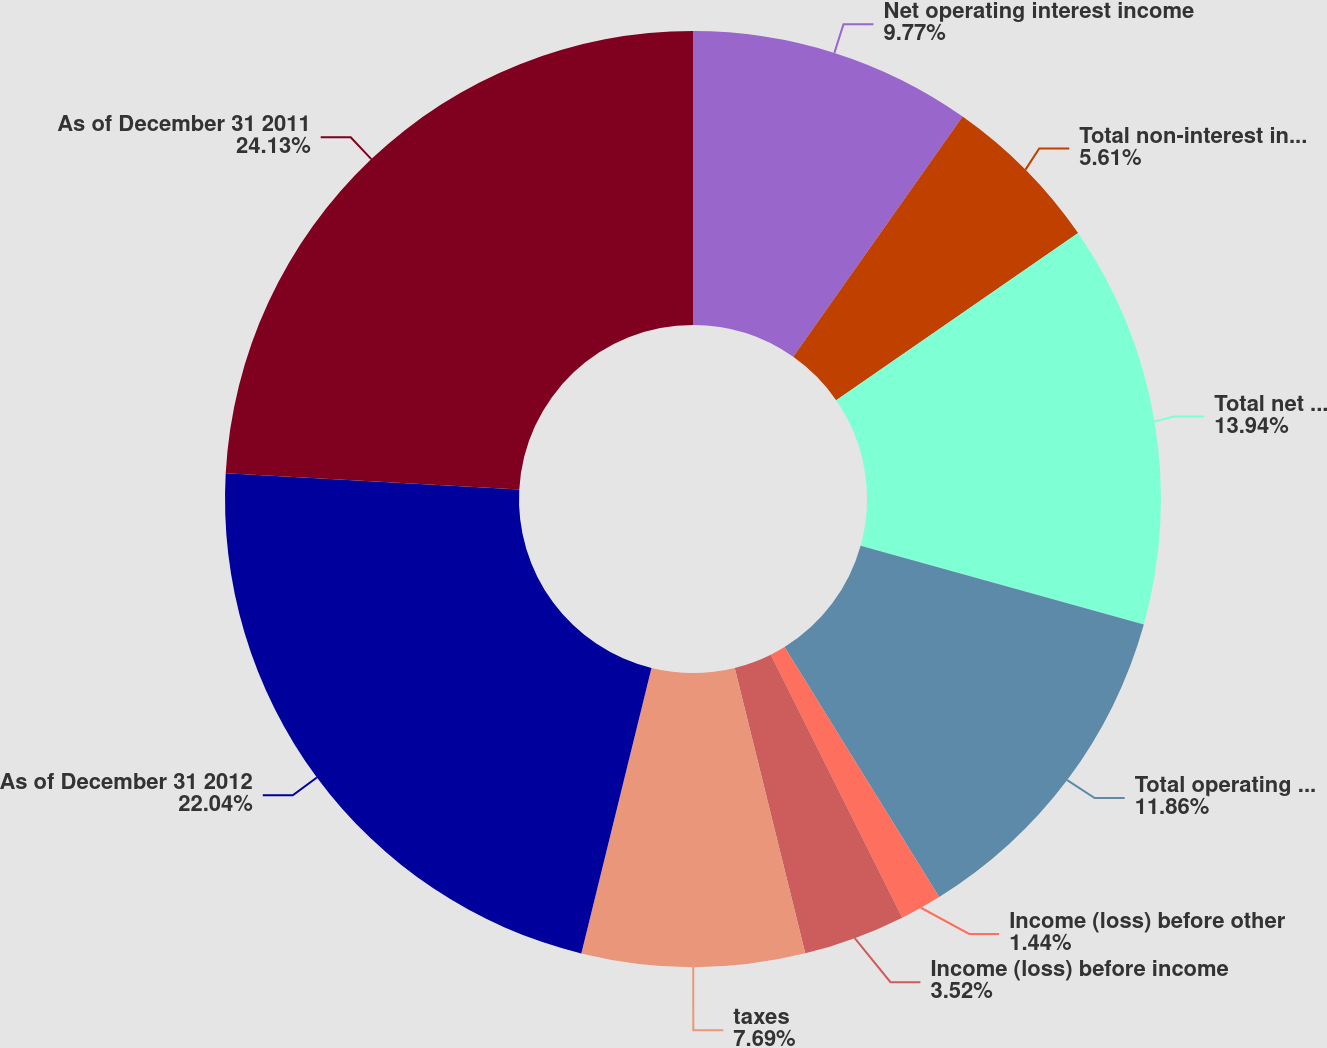Convert chart. <chart><loc_0><loc_0><loc_500><loc_500><pie_chart><fcel>Net operating interest income<fcel>Total non-interest income<fcel>Total net revenue<fcel>Total operating expense<fcel>Income (loss) before other<fcel>Income (loss) before income<fcel>taxes<fcel>As of December 31 2012<fcel>As of December 31 2011<nl><fcel>9.77%<fcel>5.61%<fcel>13.94%<fcel>11.86%<fcel>1.44%<fcel>3.52%<fcel>7.69%<fcel>22.04%<fcel>24.12%<nl></chart> 